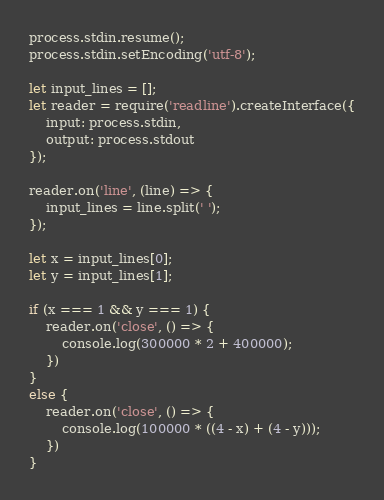<code> <loc_0><loc_0><loc_500><loc_500><_JavaScript_>process.stdin.resume();
process.stdin.setEncoding('utf-8');

let input_lines = [];
let reader = require('readline').createInterface({
    input: process.stdin,
    output: process.stdout
});

reader.on('line', (line) => {
    input_lines = line.split(' ');
});

let x = input_lines[0];
let y = input_lines[1];

if (x === 1 && y === 1) {
    reader.on('close', () => {
        console.log(300000 * 2 + 400000);
    })
}
else {
    reader.on('close', () => {
        console.log(100000 * ((4 - x) + (4 - y)));
    })
}</code> 